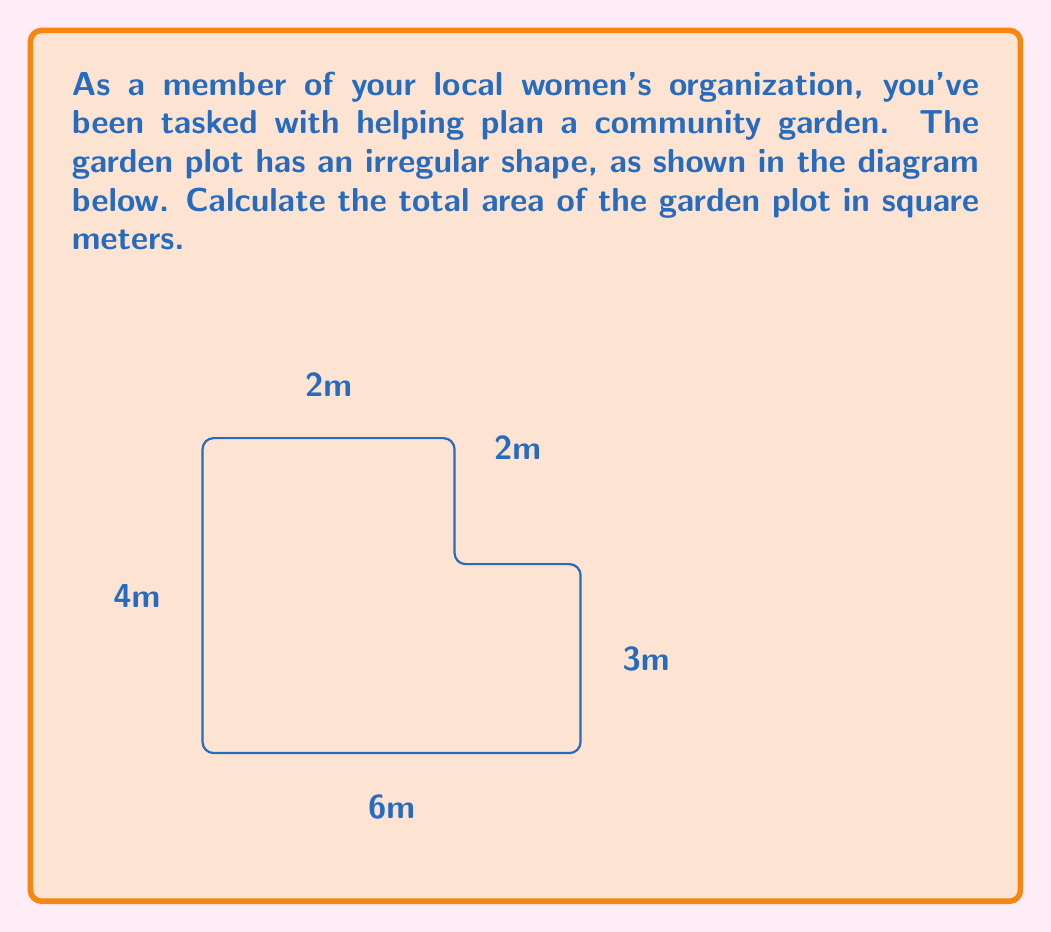Show me your answer to this math problem. To calculate the area of this irregular shape, we can divide it into rectangles and then sum their areas:

1. Divide the shape into two rectangles:
   - Rectangle A: 6m x 3m
   - Rectangle B: 4m x 2m

2. Calculate the area of Rectangle A:
   $$ A_A = 6m \times 3m = 18m^2 $$

3. Calculate the area of Rectangle B:
   $$ A_B = 4m \times 2m = 8m^2 $$

4. Sum the areas of both rectangles:
   $$ A_{total} = A_A + A_B = 18m^2 + 8m^2 = 26m^2 $$

Therefore, the total area of the garden plot is 26 square meters.
Answer: $26m^2$ 